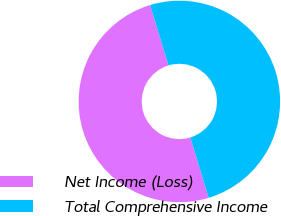Convert chart. <chart><loc_0><loc_0><loc_500><loc_500><pie_chart><fcel>Net Income (Loss)<fcel>Total Comprehensive Income<nl><fcel>50.0%<fcel>50.0%<nl></chart> 